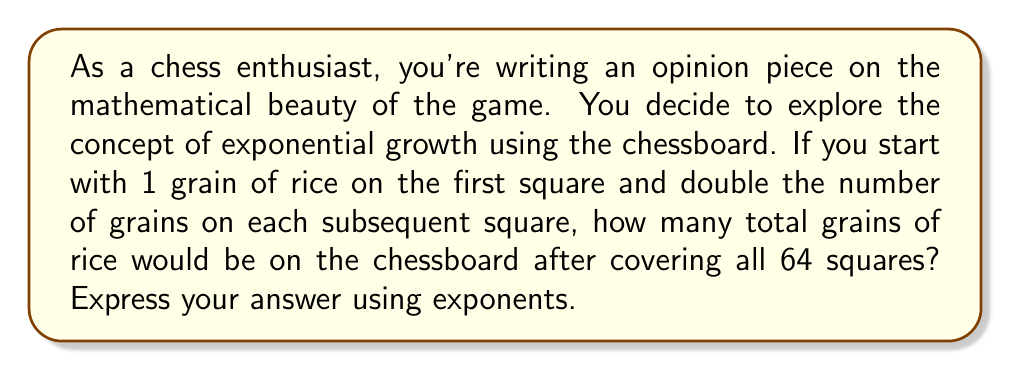What is the answer to this math problem? Let's approach this step-by-step:

1) A chessboard has 8 x 8 = 64 squares.

2) The number of grains on each square follows this pattern:
   1st square: $2^0 = 1$
   2nd square: $2^1 = 2$
   3rd square: $2^2 = 4$
   4th square: $2^3 = 8$
   ...and so on until the 64th square.

3) The total number of grains is the sum of grains on all squares:

   $S = 2^0 + 2^1 + 2^2 + 2^3 + ... + 2^{62} + 2^{63}$

4) This is a geometric series with first term $a = 1$ and common ratio $r = 2$.

5) The sum of a geometric series is given by the formula:

   $S = \frac{a(1-r^n)}{1-r}$, where $n$ is the number of terms.

6) In this case, $a = 1$, $r = 2$, and $n = 64$:

   $S = \frac{1(1-2^{64})}{1-2} = \frac{2^{64}-1}{1}$

7) Therefore, the total number of grains is $2^{64} - 1$.

This can be written as:

$$(2^{64}) - 1 = 2^{64} - 2^0$$
Answer: $2^{64} - 2^0$ 